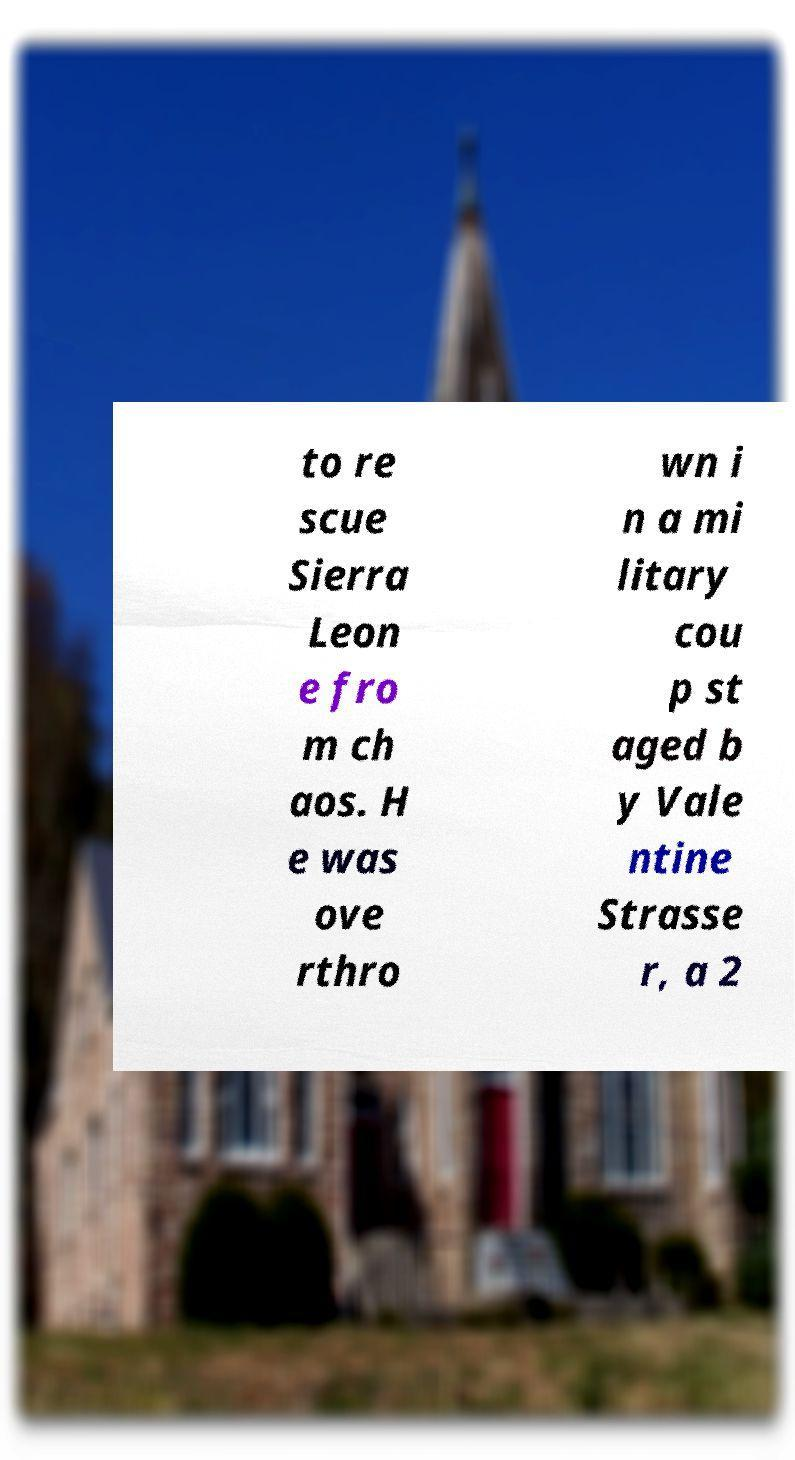There's text embedded in this image that I need extracted. Can you transcribe it verbatim? to re scue Sierra Leon e fro m ch aos. H e was ove rthro wn i n a mi litary cou p st aged b y Vale ntine Strasse r, a 2 